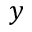<formula> <loc_0><loc_0><loc_500><loc_500>y</formula> 